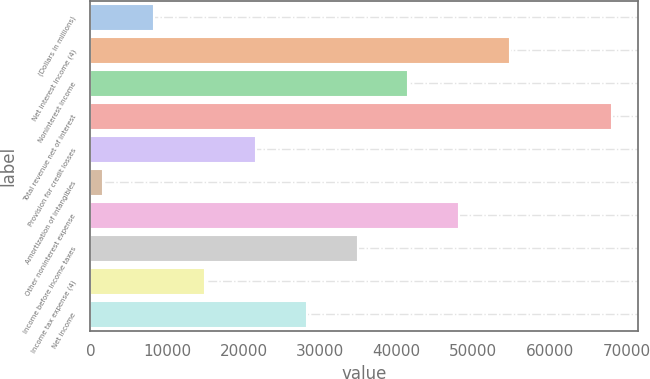Convert chart. <chart><loc_0><loc_0><loc_500><loc_500><bar_chart><fcel>(Dollars in millions)<fcel>Net interest income (4)<fcel>Noninterest income<fcel>Total revenue net of interest<fcel>Provision for credit losses<fcel>Amortization of intangibles<fcel>Other noninterest expense<fcel>Income before income taxes<fcel>Income tax expense (4)<fcel>Net income<nl><fcel>8315.2<fcel>54789.6<fcel>41511.2<fcel>68068<fcel>21593.6<fcel>1676<fcel>48150.4<fcel>34872<fcel>14954.4<fcel>28232.8<nl></chart> 